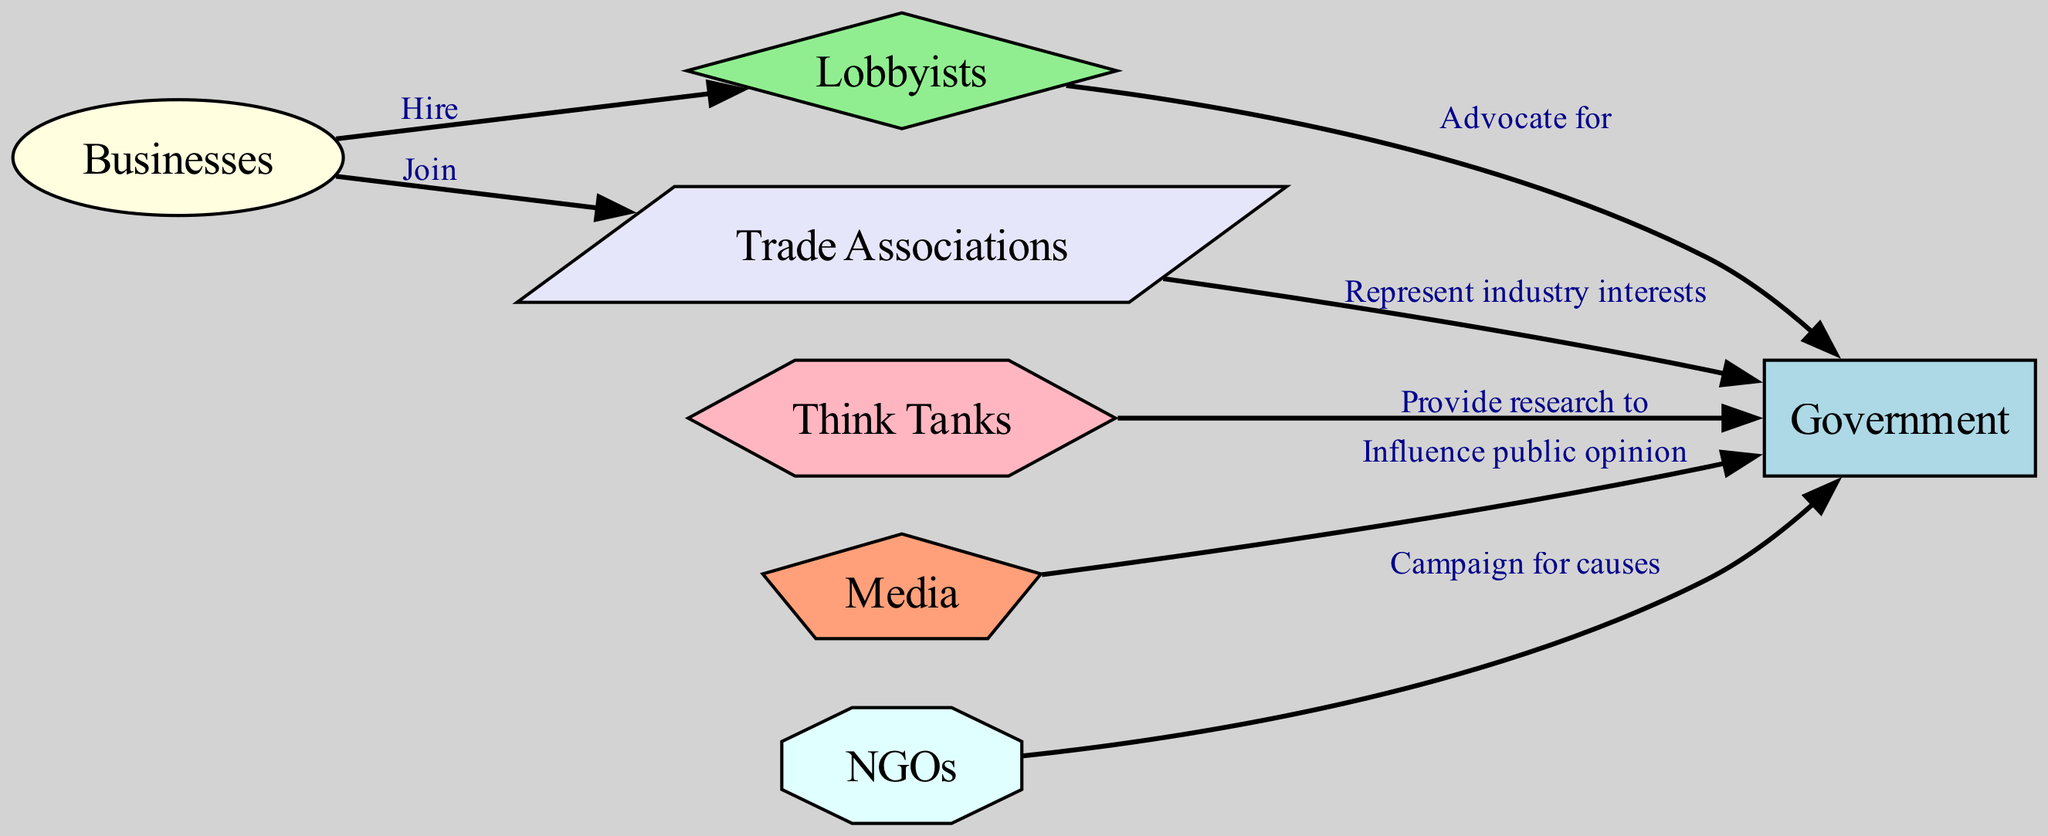What are the stakeholders represented in this concept map? The diagram contains seven stakeholders represented as nodes: Government, Businesses, Lobbyists, Think Tanks, Media, NGOs, and Trade Associations. This can be observed by identifying each labeled node from the diagram.
Answer: Government, Businesses, Lobbyists, Think Tanks, Media, NGOs, Trade Associations How many edges are in the diagram? The diagram has six edges, which represent the connections or relationships between the stakeholders. Counting each line that links one stakeholder to another confirms this total.
Answer: 6 Who influences public opinion? The Media influences public opinion according to the relationship labeled in the diagram (from Media to Government). This is illustrated by the directed edge that specifies this connection.
Answer: Media What do businesses do with trade associations? Businesses join trade associations as indicated in the diagram by the directed edge between Businesses and Trade Associations. This showcases their relationship as it moves from Businesses to Trade Associations.
Answer: Join Who advocates for the Government? Lobbyists advocate for the Government, as indicated by the directed edge labeled "Advocate for" from Lobbyists to Government in the diagram. This explicitly states the role of lobbyists in influencing the government.
Answer: Lobbyists What type of relationship does Think Tanks have with the Government? Think Tanks provide research to the Government, which is shown by the directed edge labeled "Provide research to" in the diagram connecting these two nodes. This specifies the function of think tanks in this context.
Answer: Provide research to Which stakeholder represents industry interests to the Government? Trade Associations represent industry interests to the Government, as indicated in the diagram by the edge labeled "Represent industry interests". This illustrates the function of trade associations in policy-making.
Answer: Trade Associations How many stakeholders are involved in campaigning for causes? Only one stakeholder, NGOs, is indicated to campaign for causes towards the Government according to the relationship depicted in the diagram. This is shown through the targeted connection from NGOs to Government.
Answer: 1 What color represents Lobbyists in the diagram? Lobbyists are represented in light green color in the diagram as a specific style assigned in the node definitions. This color helps differentiate Lobbyists from other stakeholders.
Answer: Light green 